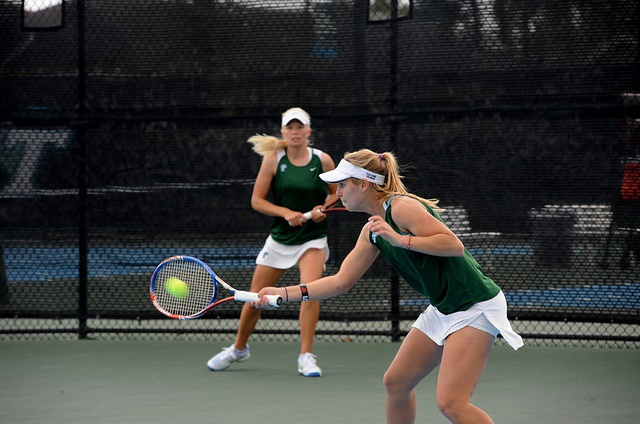Describe the objects in this image and their specific colors. I can see people in black, brown, gray, and lavender tones, people in black, salmon, and lightgray tones, tennis racket in black, darkgray, gray, and lightgray tones, bench in black, gray, and darkgray tones, and bench in black, gray, and darkgray tones in this image. 